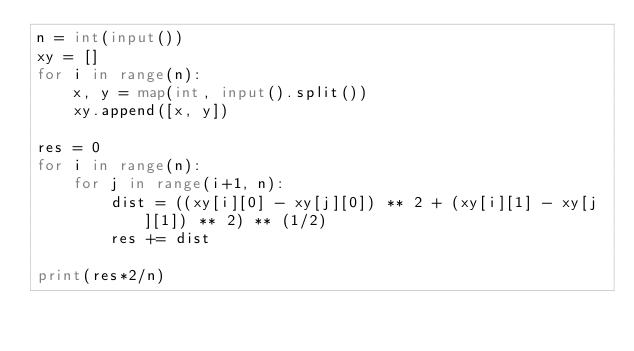<code> <loc_0><loc_0><loc_500><loc_500><_Python_>n = int(input())
xy = []
for i in range(n):
    x, y = map(int, input().split())
    xy.append([x, y])

res = 0
for i in range(n):
    for j in range(i+1, n):
        dist = ((xy[i][0] - xy[j][0]) ** 2 + (xy[i][1] - xy[j][1]) ** 2) ** (1/2)
        res += dist

print(res*2/n)</code> 